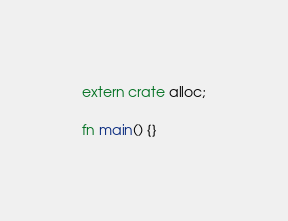<code> <loc_0><loc_0><loc_500><loc_500><_Rust_>extern crate alloc;

fn main() {}
</code> 